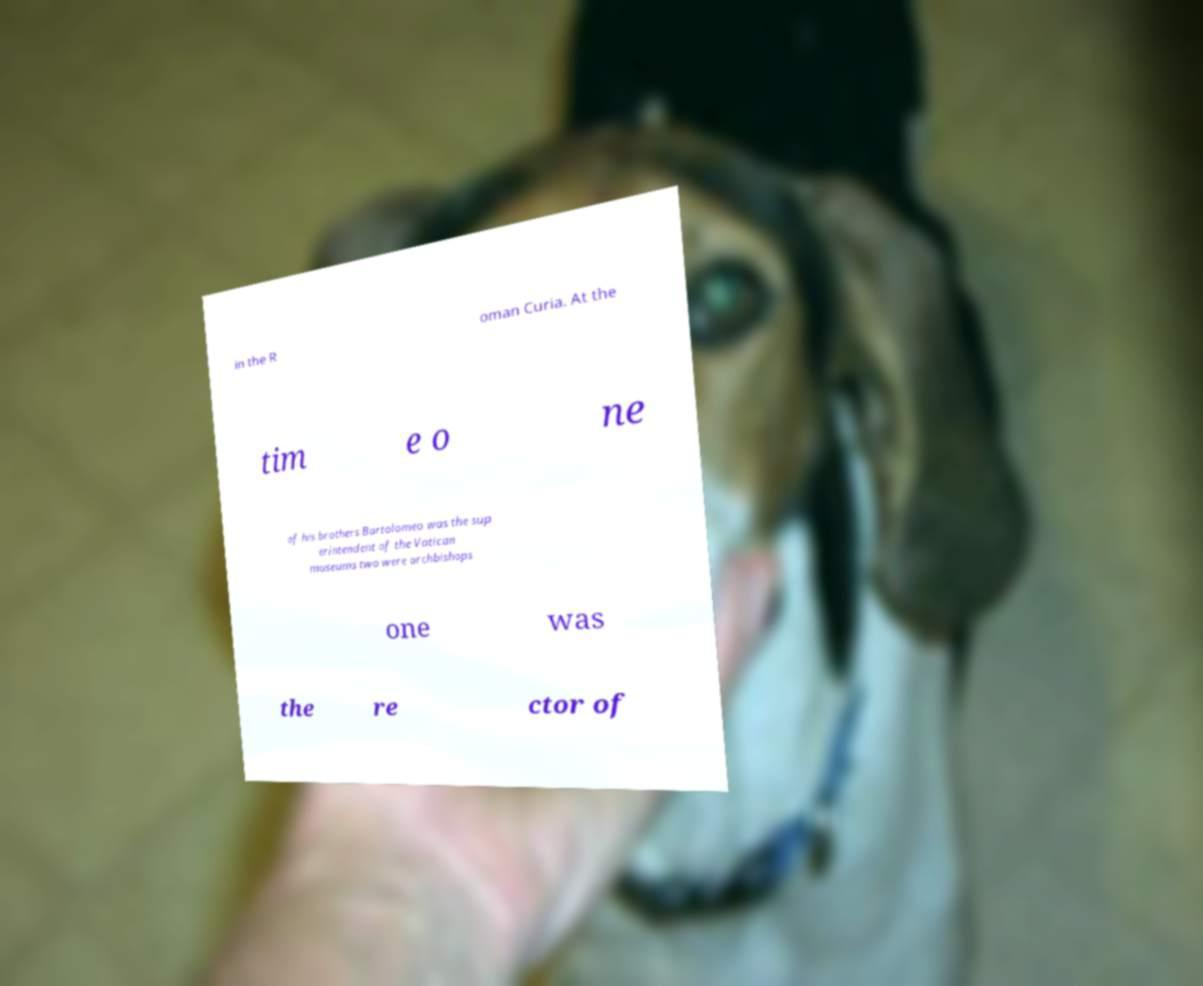Can you accurately transcribe the text from the provided image for me? in the R oman Curia. At the tim e o ne of his brothers Bartolomeo was the sup erintendent of the Vatican museums two were archbishops one was the re ctor of 